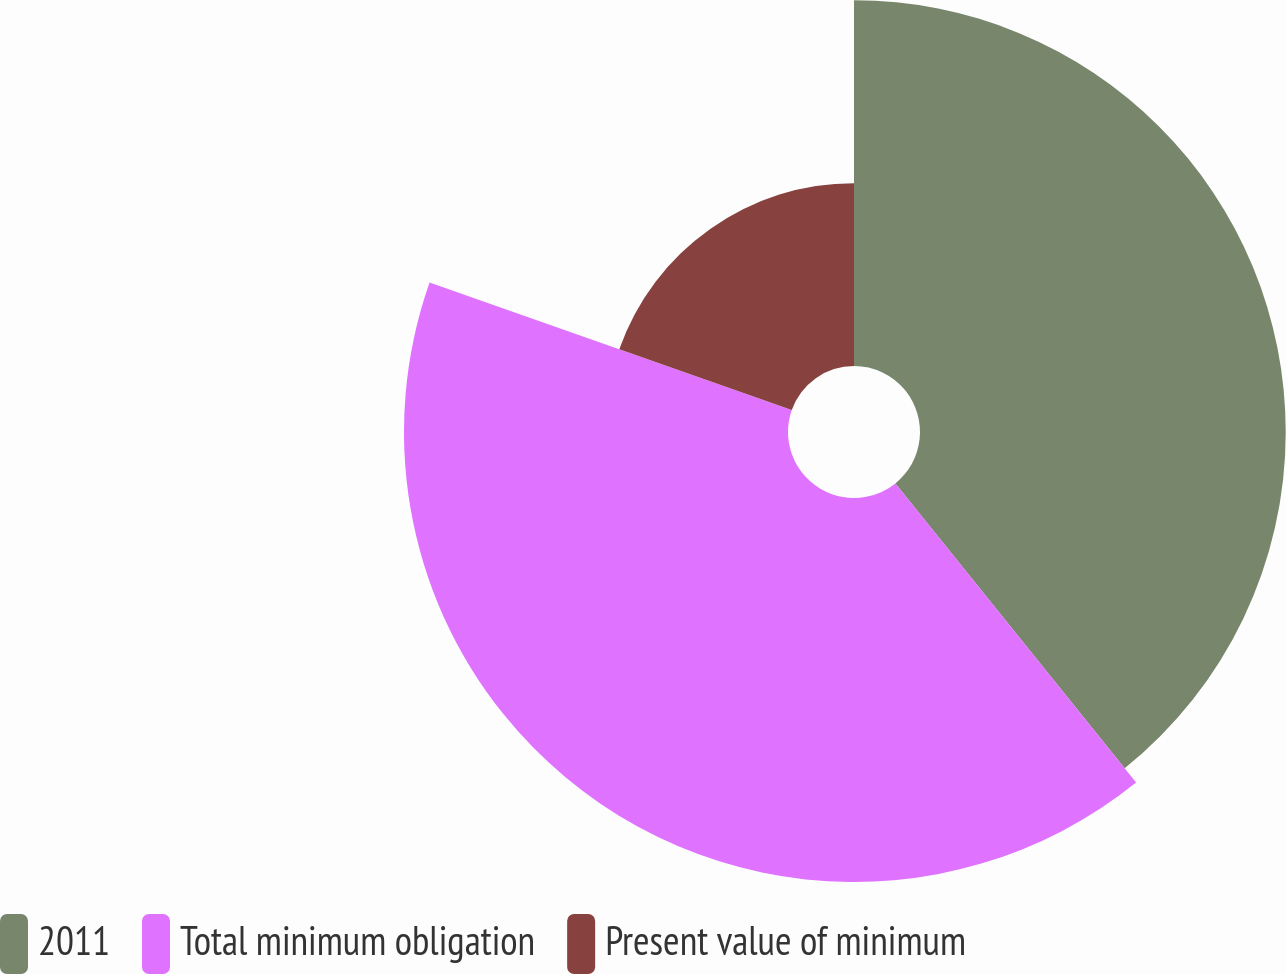Convert chart. <chart><loc_0><loc_0><loc_500><loc_500><pie_chart><fcel>2011<fcel>Total minimum obligation<fcel>Present value of minimum<nl><fcel>39.22%<fcel>41.18%<fcel>19.61%<nl></chart> 